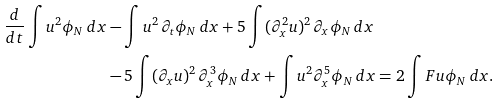Convert formula to latex. <formula><loc_0><loc_0><loc_500><loc_500>\frac { d } { d t } \int u ^ { 2 } \phi _ { N } \, d x & - \int u ^ { 2 } \, \partial _ { t } \phi _ { N } \, d x + 5 \int ( \partial _ { x } ^ { 2 } u ) ^ { 2 } \, \partial _ { x } \phi _ { N } \, d x \\ & - 5 \int ( \partial _ { x } u ) ^ { 2 } \, \partial _ { x } ^ { 3 } \phi _ { N } \, d x + \int u ^ { 2 } \partial _ { x } ^ { 5 } \phi _ { N } \, d x = 2 \int F u \phi _ { N } \, d x .</formula> 